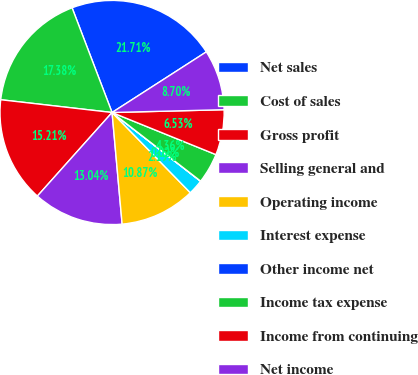Convert chart. <chart><loc_0><loc_0><loc_500><loc_500><pie_chart><fcel>Net sales<fcel>Cost of sales<fcel>Gross profit<fcel>Selling general and<fcel>Operating income<fcel>Interest expense<fcel>Other income net<fcel>Income tax expense<fcel>Income from continuing<fcel>Net income<nl><fcel>21.71%<fcel>17.38%<fcel>15.21%<fcel>13.04%<fcel>10.87%<fcel>2.19%<fcel>0.02%<fcel>4.36%<fcel>6.53%<fcel>8.7%<nl></chart> 